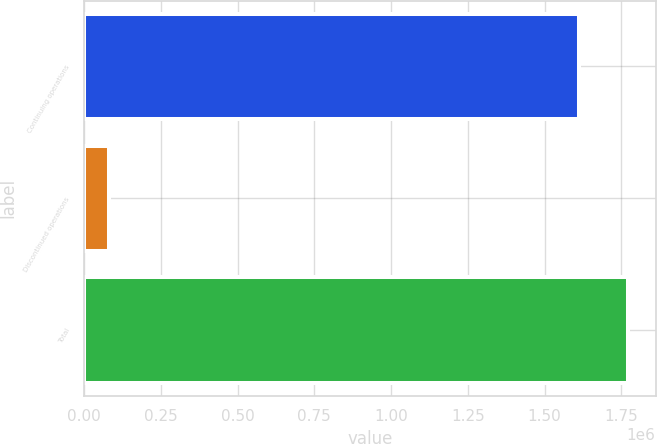Convert chart to OTSL. <chart><loc_0><loc_0><loc_500><loc_500><bar_chart><fcel>Continuing operations<fcel>Discontinued operations<fcel>Total<nl><fcel>1.61206e+06<fcel>79953<fcel>1.77327e+06<nl></chart> 